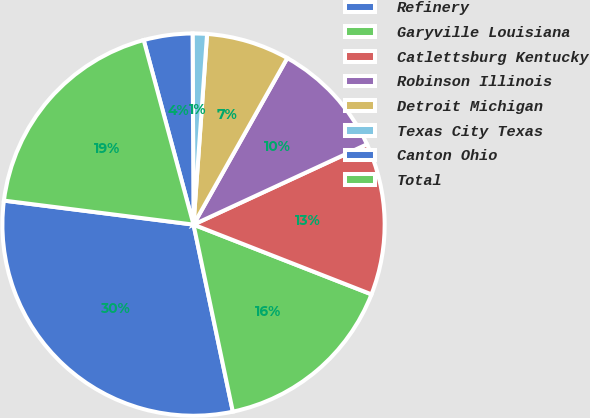<chart> <loc_0><loc_0><loc_500><loc_500><pie_chart><fcel>Refinery<fcel>Garyville Louisiana<fcel>Catlettsburg Kentucky<fcel>Robinson Illinois<fcel>Detroit Michigan<fcel>Texas City Texas<fcel>Canton Ohio<fcel>Total<nl><fcel>30.31%<fcel>15.76%<fcel>12.85%<fcel>9.94%<fcel>7.03%<fcel>1.21%<fcel>4.12%<fcel>18.8%<nl></chart> 